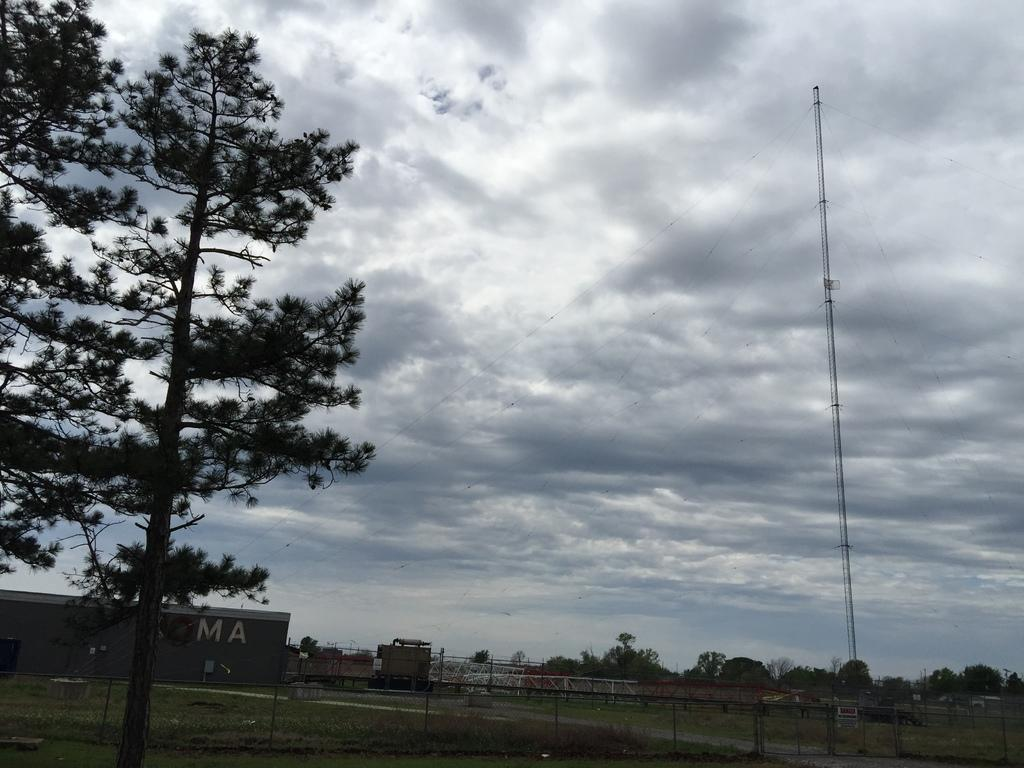What is the main setting of the image? There is a big field in the image. What type of natural elements can be seen in the image? There are many trees in the image. Are there any man-made structures visible in the image? Yes, there is some fence visible in the image. What type of industry can be seen operating in the field in the image? There is no industry present in the image; it features a big field with many trees and some fence. Can you tell me how many dinosaurs are grazing in the field in the image? There are no dinosaurs present in the image; it features a big field with many trees and some fence. 